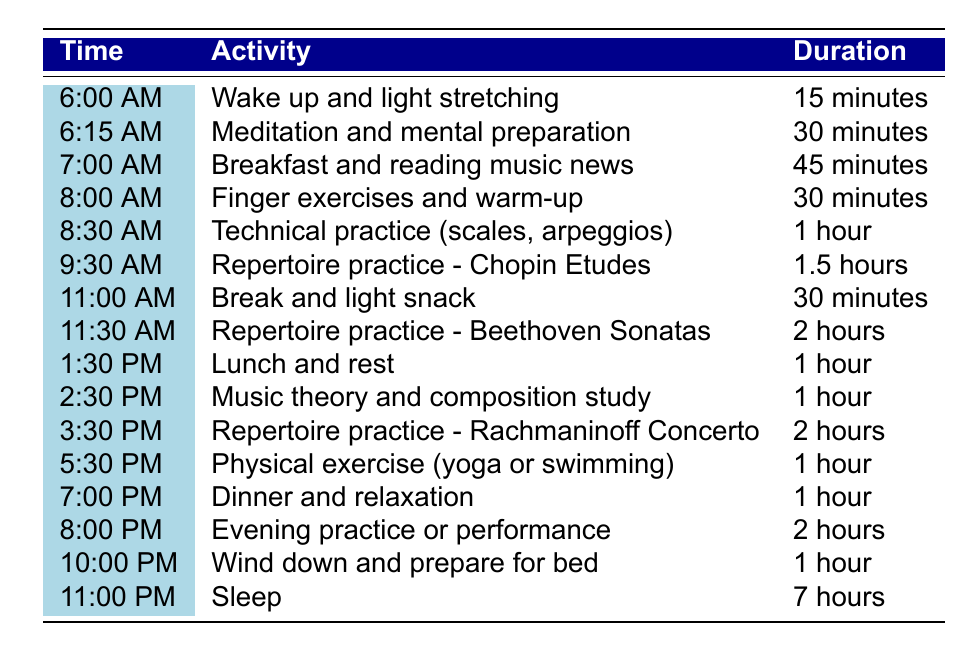What time does the pianist start their practice routine? The first activity listed in the table is "Wake up and light stretching," which occurs at 6:00 AM.
Answer: 6:00 AM How long is the pianist's meditation session? According to the table, the meditation session lasts for 30 minutes, starting at 6:15 AM.
Answer: 30 minutes What activities follow breakfast? After breakfast and reading music news, which lasts for 45 minutes until 8:00 AM, the next activities are "Finger exercises and warm-up" and "Technical practice."
Answer: Finger exercises and warm-up, Technical practice What is the total duration of the repertoire practice for Chopin Etudes and Beethoven Sonatas combined? The duration for Chopin Etudes is 1.5 hours and for Beethoven Sonatas is 2 hours. Combining these gives 1.5 + 2 = 3.5 hours.
Answer: 3.5 hours Does the pianist have a break between the practices? Yes, there is a break and light snack scheduled at 11:00 AM, which lasts for 30 minutes after the morning practice.
Answer: Yes What is the last activity of the day before sleep? The table shows that the last activity before sleep, which starts at 11:00 PM, is "Wind down and prepare for bed" at 10:00 PM.
Answer: Wind down and prepare for bed How many hours in total are dedicated to practice in the afternoon? In the afternoon, the practice sessions are "Music theory study" (1 hour) and "Repertoire practice - Rachmaninoff Concerto" (2 hours). Adding these gives 1 + 2 = 3 hours.
Answer: 3 hours What proportion of the day is spent on sleep compared to the total daily routine? The pianist sleeps for 7 hours and has a total daily schedule of 24 hours. The proportion of sleep is 7/24, which equals approximately 29.17%.
Answer: Approximately 29.17% Is there a physical exercise activity in the schedule? Yes, there is a physical exercise activity listed at 5:30 PM, which involves either yoga or swimming for 1 hour.
Answer: Yes How much time is allocated for dinner and relaxation? The table indicates that dinner and relaxation take up 1 hour, scheduled from 7:00 PM to 8:00 PM.
Answer: 1 hour 